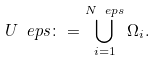<formula> <loc_0><loc_0><loc_500><loc_500>U _ { \ } e p s \colon = \bigcup _ { i = 1 } ^ { N _ { \ } e p s } \Omega _ { i } .</formula> 